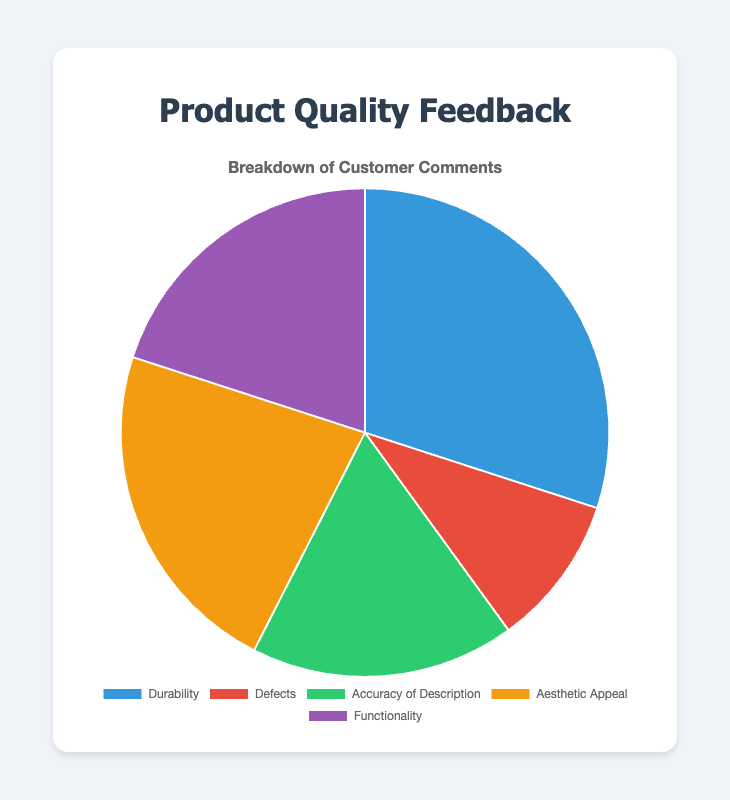Which category has the highest number of comments? The slice representing "Durability" is the largest in the pie chart, indicating it has the highest number of comments.
Answer: Durability Which categories have fewer comments than "Aesthetic Appeal"? "Defects," "Accuracy of Description," and "Functionality" slices are smaller than the "Aesthetic Appeal" slice in the pie chart.
Answer: Defects, Accuracy of Description, Functionality What's the total number of comments represented in the chart? Sum of all data points: 120 (Durability) + 40 (Defects) + 70 (Accuracy of Description) + 90 (Aesthetic Appeal) + 80 (Functionality) = 400 comments.
Answer: 400 How many more comments are there for "Durability" compared to "Functionality"? Subtract the number of comments for "Functionality" from "Durability": 120 (Durability) - 80 (Functionality).
Answer: 40 What is the percentage of comments related to "Accuracy of Description"? Divide the comments for "Accuracy of Description" by the total comments and multiply by 100: (70 / 400) * 100 = 17.5%.
Answer: 17.5% Which category has the smallest slice in the pie chart? The "Defects" category has the smallest slice in the pie chart, indicating the least number of comments.
Answer: Defects Are there more comments on "Functionality" or on "Aesthetic Appeal"? The slice for "Aesthetic Appeal" is larger than the slice for "Functionality" in the pie chart.
Answer: Aesthetic Appeal What is the combined number of comments for "Accuracy of Description" and "Aesthetic Appeal"? Sum of comments for "Accuracy of Description" and "Aesthetic Appeal": 70 (Accuracy of Description) + 90 (Aesthetic Appeal) = 160.
Answer: 160 Compare the number of comments about "Durability" and "Defects". How many times more comments are there for "Durability"? Divide the number of comments for "Durability" by the number of comments for "Defects": 120 / 40 = 3 times more.
Answer: 3 What is the average number of comments per category? Sum of all comments divided by the number of categories: 400 (total comments) / 5 (categories) = 80 comments per category.
Answer: 80 